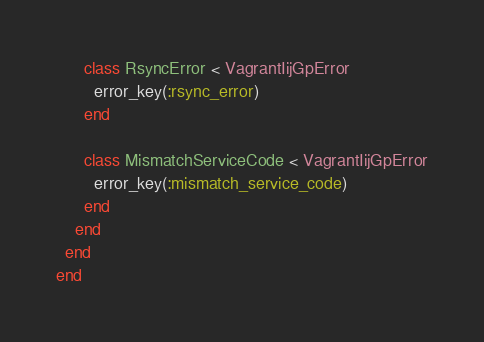<code> <loc_0><loc_0><loc_500><loc_500><_Ruby_>      class RsyncError < VagrantIijGpError
        error_key(:rsync_error)
      end

      class MismatchServiceCode < VagrantIijGpError
        error_key(:mismatch_service_code)
      end
    end
  end
end
</code> 